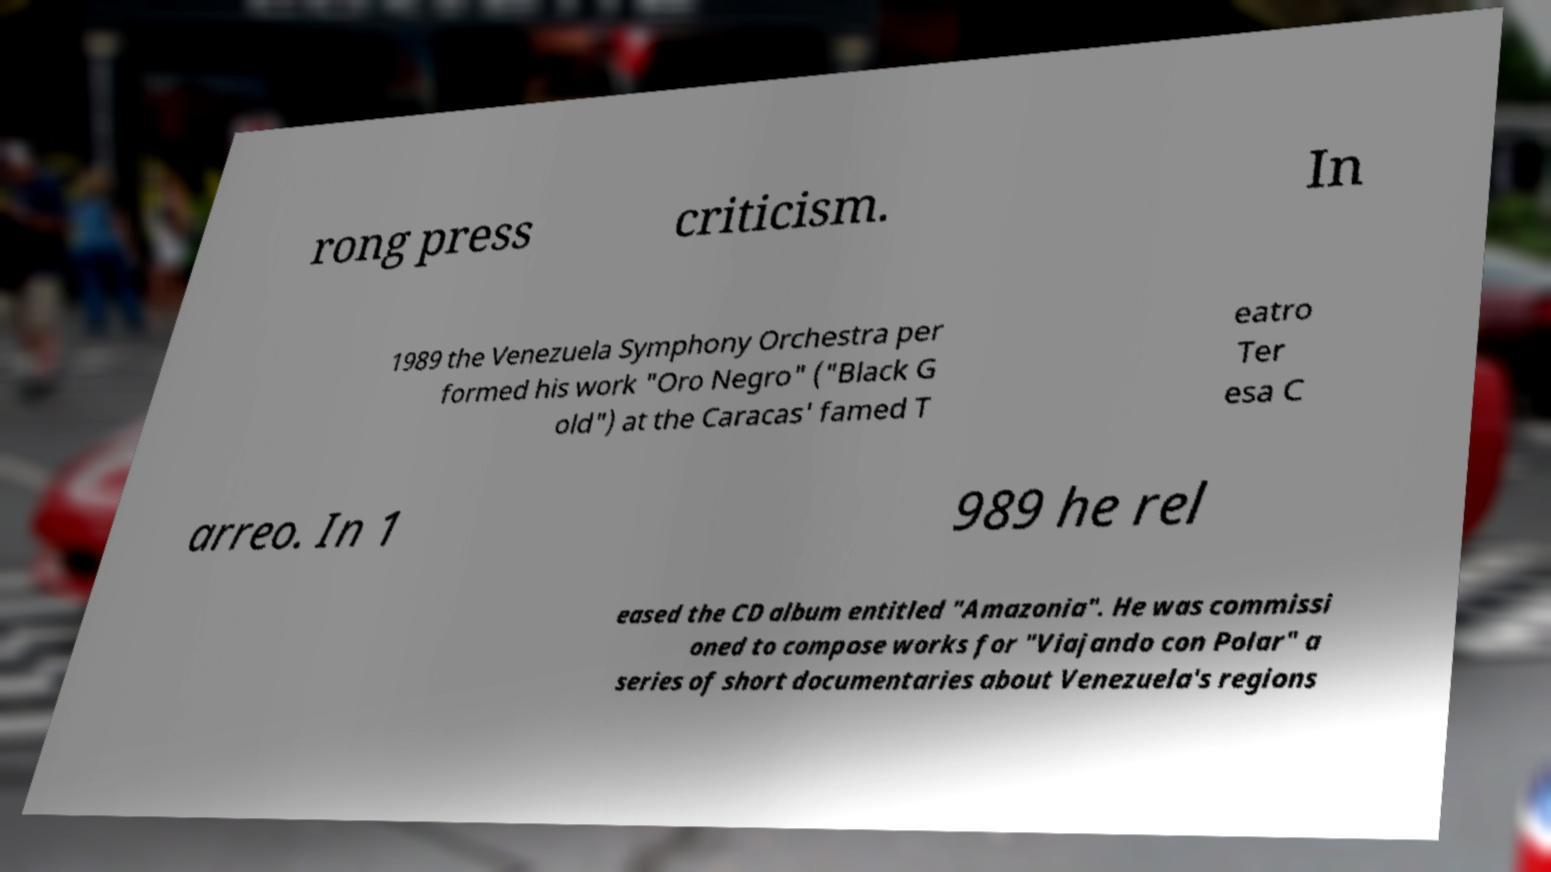Could you assist in decoding the text presented in this image and type it out clearly? rong press criticism. In 1989 the Venezuela Symphony Orchestra per formed his work "Oro Negro" ("Black G old") at the Caracas' famed T eatro Ter esa C arreo. In 1 989 he rel eased the CD album entitled "Amazonia". He was commissi oned to compose works for "Viajando con Polar" a series of short documentaries about Venezuela's regions 